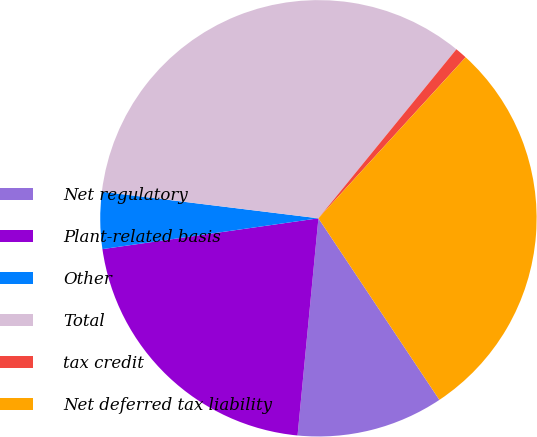<chart> <loc_0><loc_0><loc_500><loc_500><pie_chart><fcel>Net regulatory<fcel>Plant-related basis<fcel>Other<fcel>Total<fcel>tax credit<fcel>Net deferred tax liability<nl><fcel>10.88%<fcel>21.22%<fcel>4.2%<fcel>33.95%<fcel>0.89%<fcel>28.86%<nl></chart> 